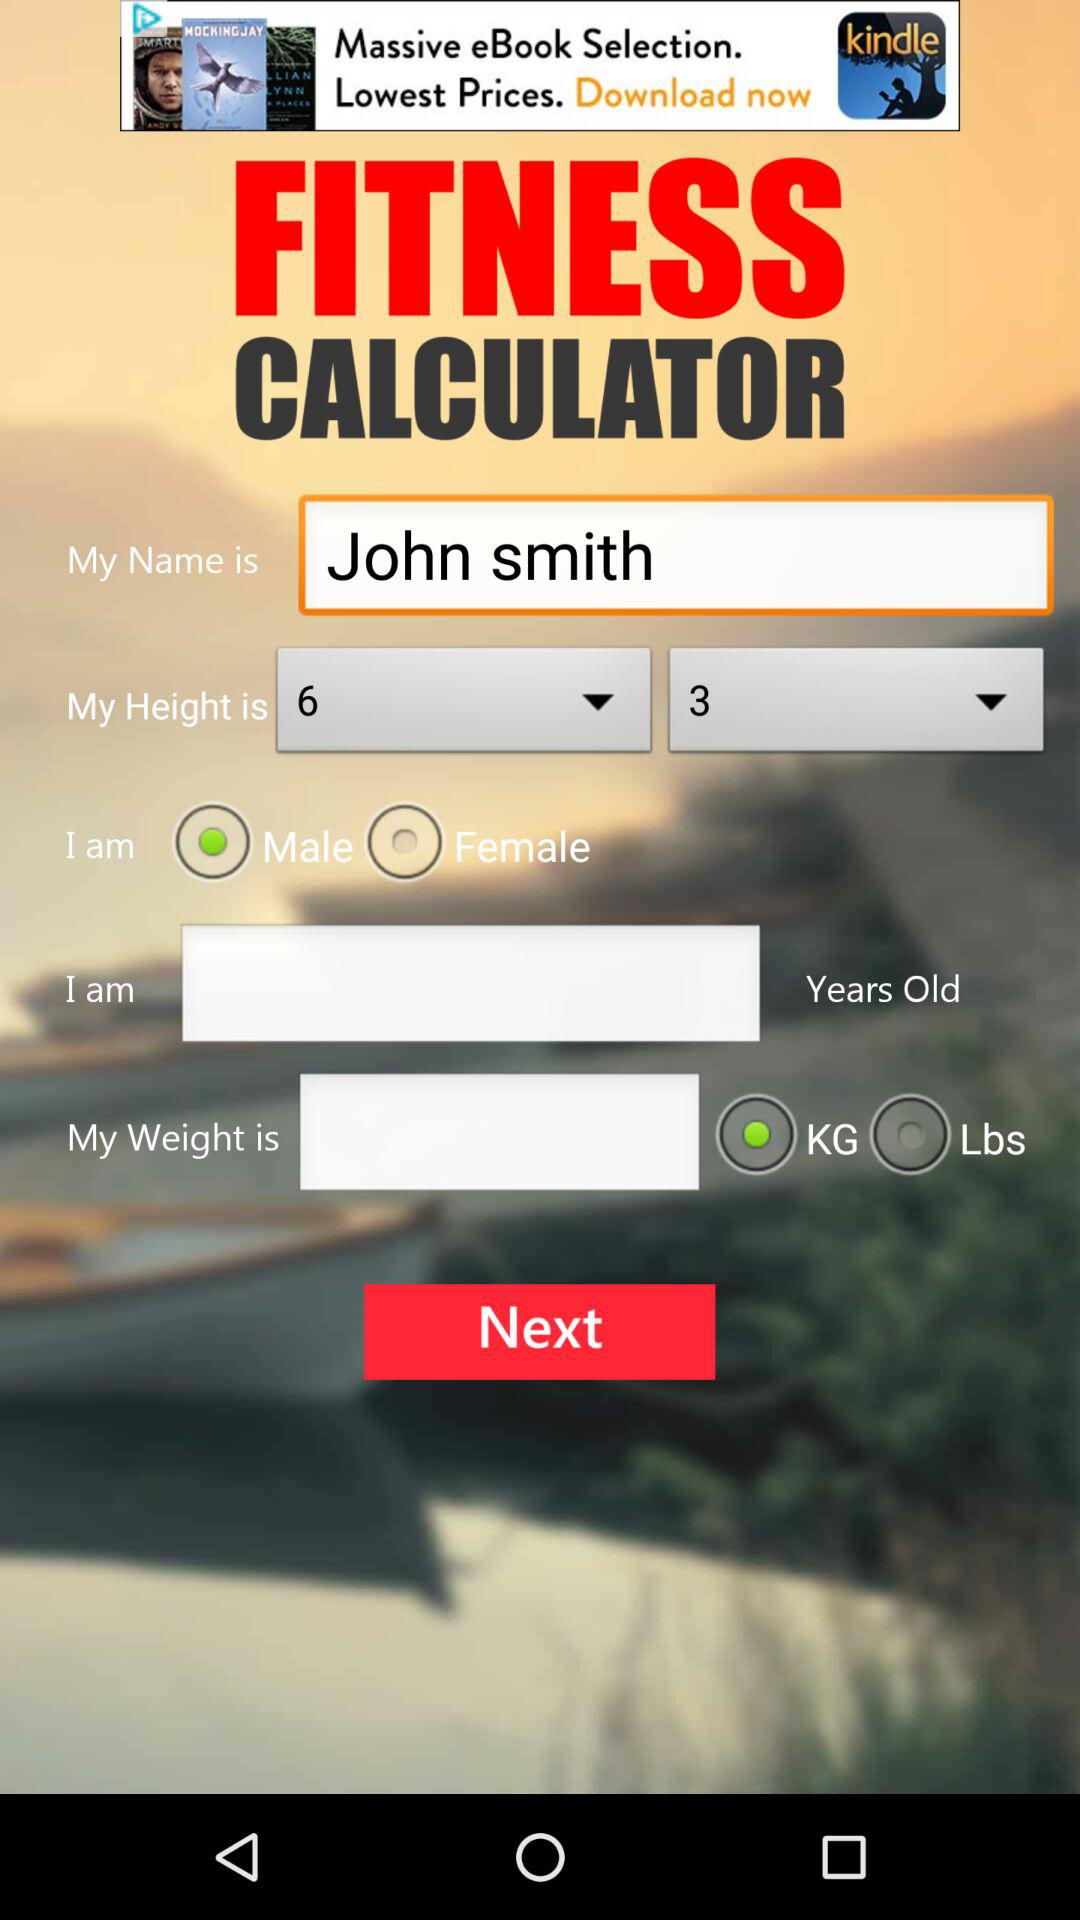What is the selected weight unit? The selected weight unit is the kilogram. 